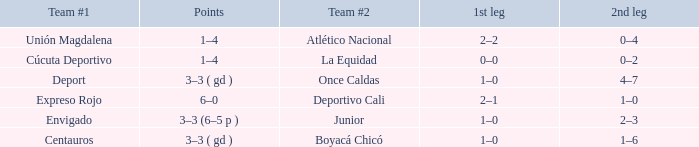What is the 1st leg with a junior team #2? 1–0. Would you mind parsing the complete table? {'header': ['Team #1', 'Points', 'Team #2', '1st leg', '2nd leg'], 'rows': [['Unión Magdalena', '1–4', 'Atlético Nacional', '2–2', '0–4'], ['Cúcuta Deportivo', '1–4', 'La Equidad', '0–0', '0–2'], ['Deport', '3–3 ( gd )', 'Once Caldas', '1–0', '4–7'], ['Expreso Rojo', '6–0', 'Deportivo Cali', '2–1', '1–0'], ['Envigado', '3–3 (6–5 p )', 'Junior', '1–0', '2–3'], ['Centauros', '3–3 ( gd )', 'Boyacá Chicó', '1–0', '1–6']]} 